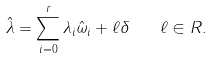<formula> <loc_0><loc_0><loc_500><loc_500>\hat { \lambda } = \sum _ { i = 0 } ^ { r } \lambda _ { i } \hat { \omega } _ { i } + \ell \delta \quad \ell \in R .</formula> 